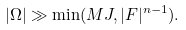<formula> <loc_0><loc_0><loc_500><loc_500>| \Omega | \gg \min ( M J , | F | ^ { n - 1 } ) .</formula> 